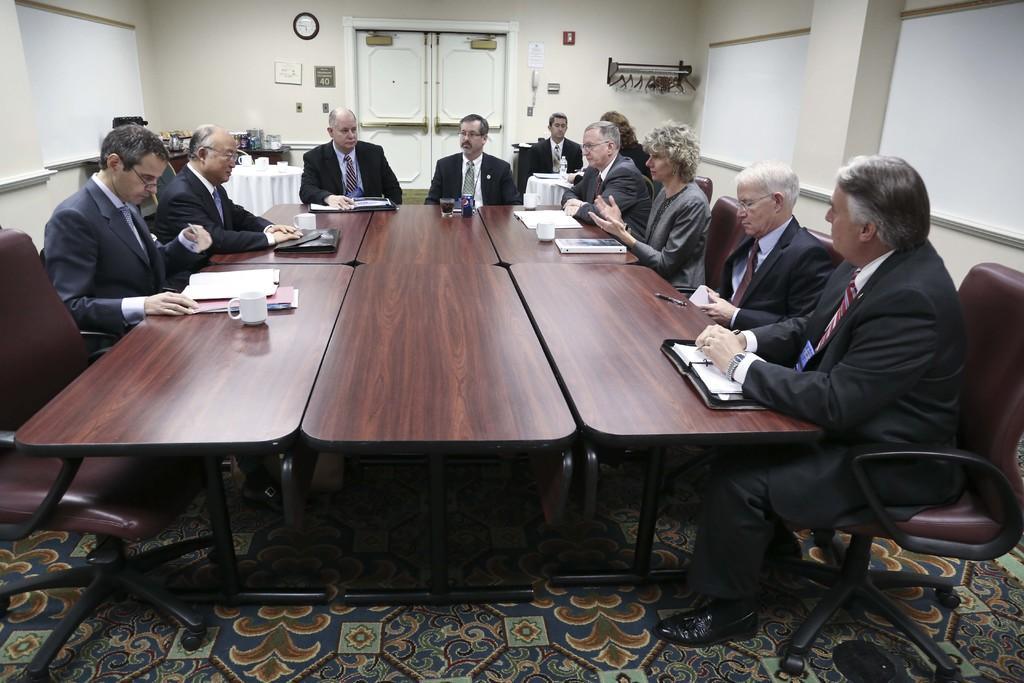How would you summarize this image in a sentence or two? In this image, group of people are sat on the chair. In the middle, there are so many tables, few items are placed on it. At the bottom ,we can see a mat. And top of the image, we can see white door, few items are placed on the wall. And right side and left side, we can see a white color. On the left there is a wooden table, few items are there. 